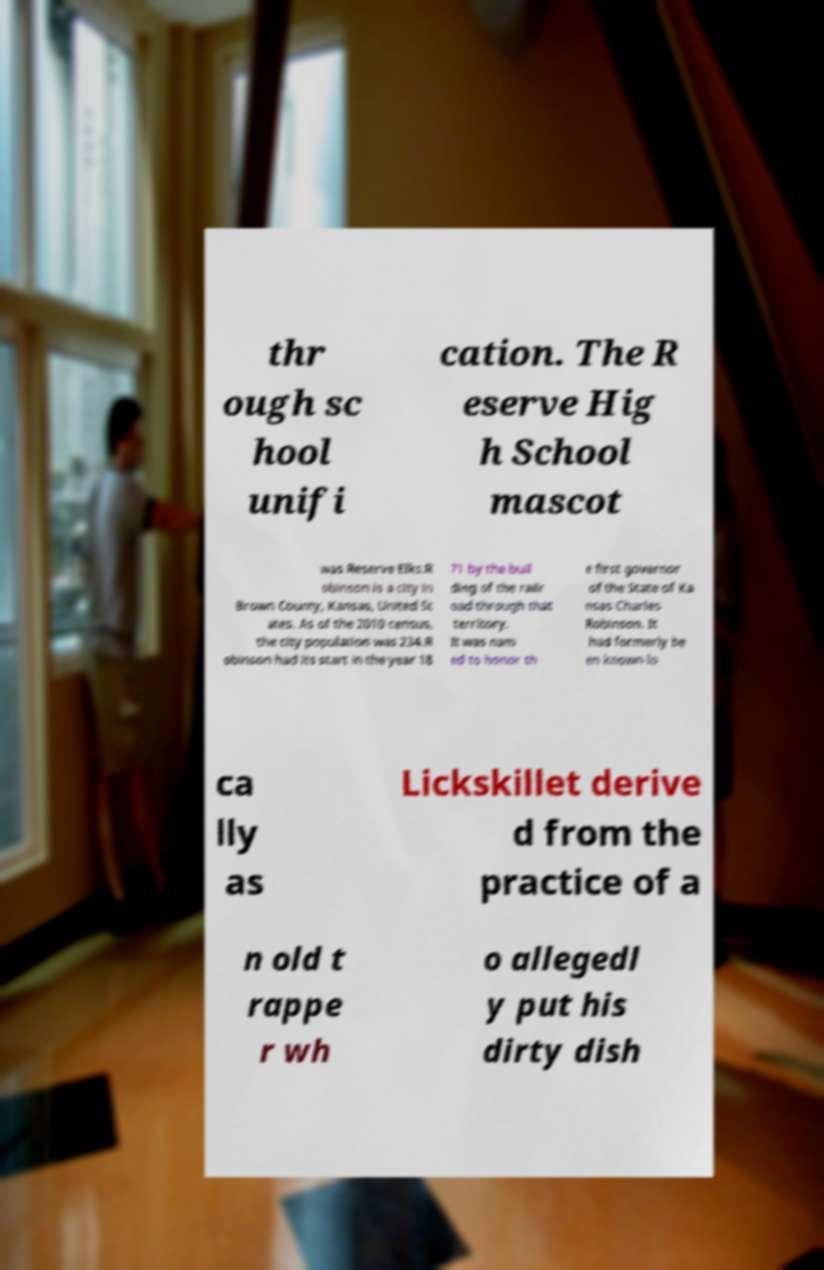Could you assist in decoding the text presented in this image and type it out clearly? thr ough sc hool unifi cation. The R eserve Hig h School mascot was Reserve Elks.R obinson is a city in Brown County, Kansas, United St ates. As of the 2010 census, the city population was 234.R obinson had its start in the year 18 71 by the buil ding of the railr oad through that territory. It was nam ed to honor th e first governor of the State of Ka nsas Charles Robinson. It had formerly be en known lo ca lly as Lickskillet derive d from the practice of a n old t rappe r wh o allegedl y put his dirty dish 